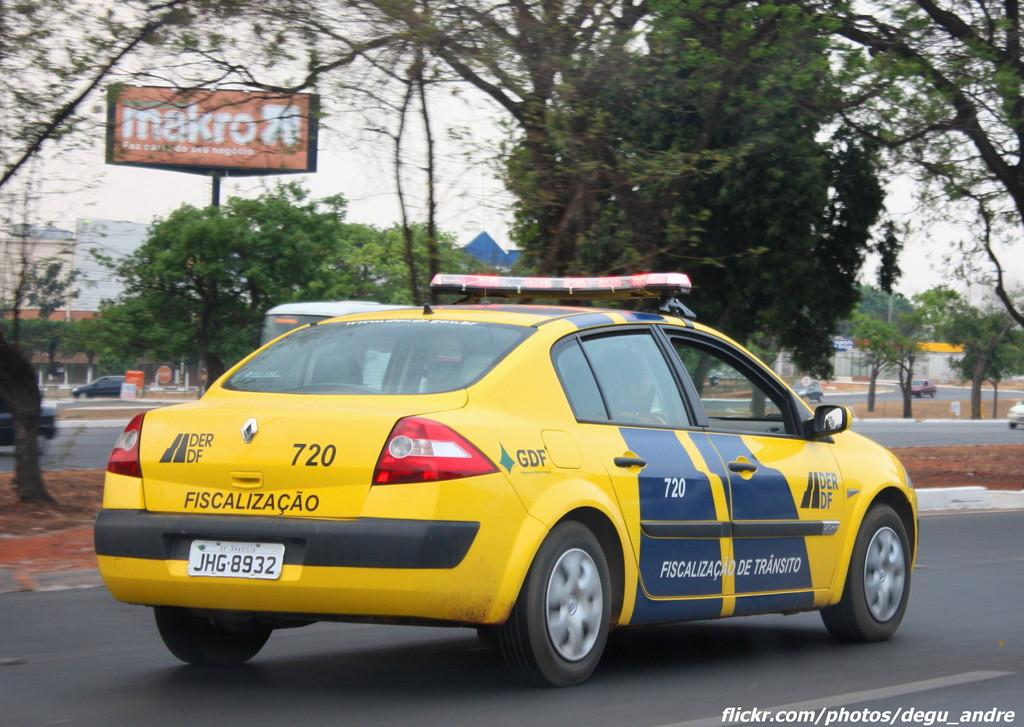<image>
Present a compact description of the photo's key features. A yellow and blue taxi, number 720 heading to the right. 